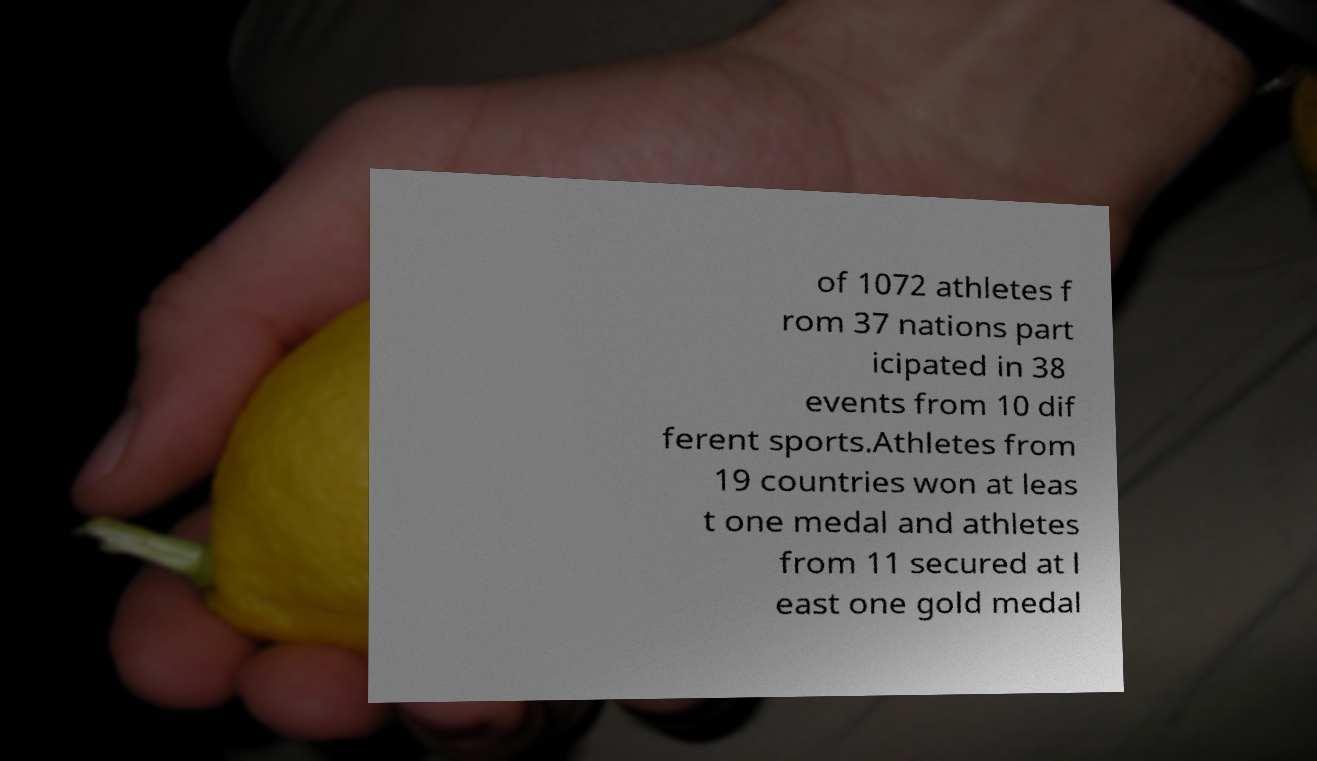I need the written content from this picture converted into text. Can you do that? of 1072 athletes f rom 37 nations part icipated in 38 events from 10 dif ferent sports.Athletes from 19 countries won at leas t one medal and athletes from 11 secured at l east one gold medal 